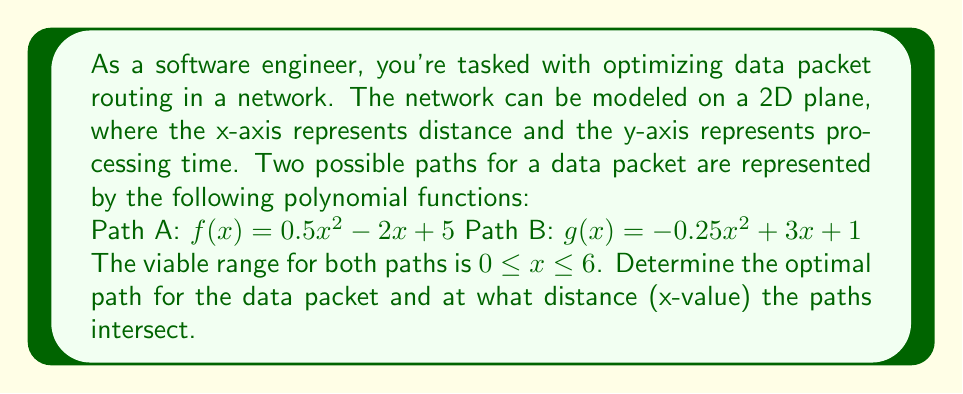What is the answer to this math problem? To solve this problem, we need to follow these steps:

1. Find the intersection point(s) of the two polynomial functions.
2. Compare the processing times (y-values) of both paths within the viable range.

Step 1: Finding the intersection point(s)

To find where the paths intersect, we set the functions equal to each other:

$f(x) = g(x)$
$0.5x^2 - 2x + 5 = -0.25x^2 + 3x + 1$

Rearranging the equation:
$0.75x^2 - 5x + 4 = 0$

This is a quadratic equation. We can solve it using the quadratic formula:
$x = \frac{-b \pm \sqrt{b^2 - 4ac}}{2a}$

Where $a = 0.75$, $b = -5$, and $c = 4$

$x = \frac{5 \pm \sqrt{25 - 12}}{1.5} = \frac{5 \pm \sqrt{13}}{1.5}$

$x_1 = \frac{5 + \sqrt{13}}{1.5} \approx 4.74$
$x_2 = \frac{5 - \sqrt{13}}{1.5} \approx 1.93$

Both of these x-values are within the viable range of $0 \leq x \leq 6$.

Step 2: Comparing processing times

To determine the optimal path, we need to compare the y-values (processing times) of both functions:

- For $0 \leq x < 1.93$, $g(x) < f(x)$, so Path B is optimal.
- For $1.93 < x < 4.74$, $f(x) < g(x)$, so Path A is optimal.
- For $4.74 < x \leq 6$, $g(x) < f(x)$, so Path B is optimal.

Therefore, the optimal path changes depending on the distance. The data packet should follow Path B initially, switch to Path A at $x \approx 1.93$, and then switch back to Path B at $x \approx 4.74$.
Answer: The optimal path for the data packet changes at the intersection points. The paths intersect at $x \approx 1.93$ and $x \approx 4.74$. The optimal route is:
- Path B for $0 \leq x < 1.93$
- Path A for $1.93 < x < 4.74$
- Path B for $4.74 < x \leq 6$ 